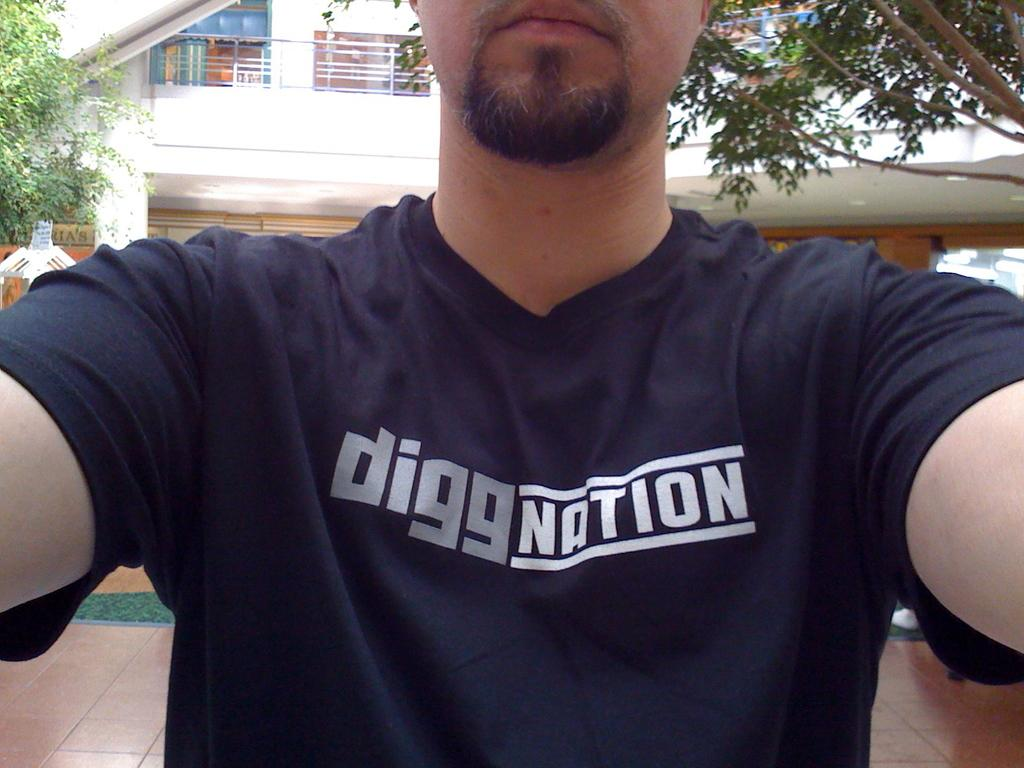<image>
Write a terse but informative summary of the picture. A man wearing a blue shirt with the text diggnation on its center. 